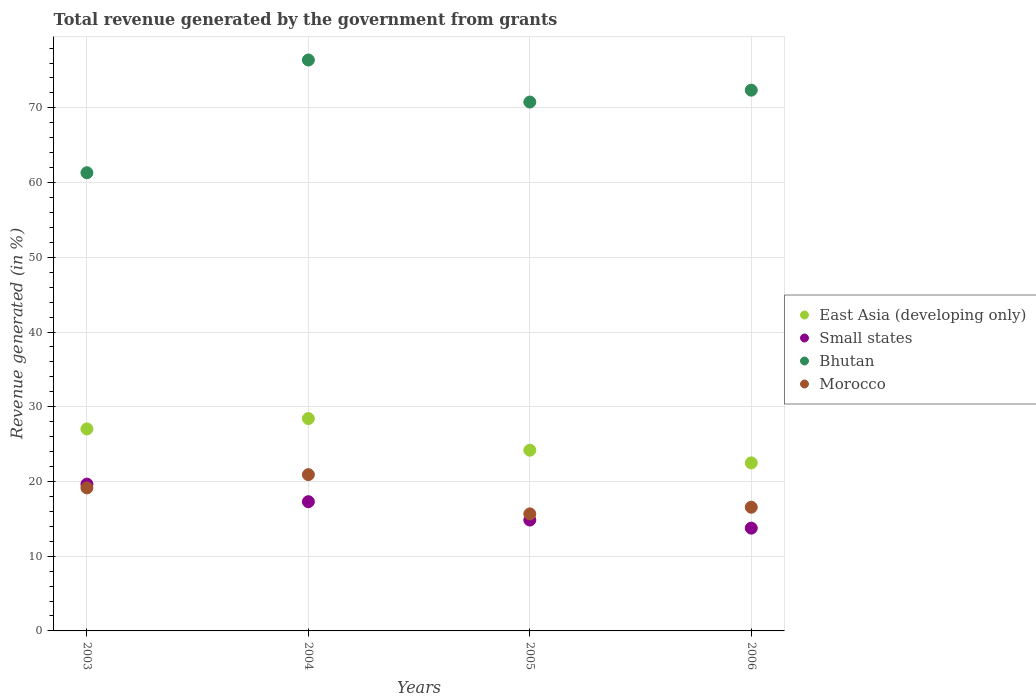What is the total revenue generated in Small states in 2005?
Ensure brevity in your answer.  14.84. Across all years, what is the maximum total revenue generated in East Asia (developing only)?
Your answer should be compact. 28.42. Across all years, what is the minimum total revenue generated in Small states?
Ensure brevity in your answer.  13.76. In which year was the total revenue generated in East Asia (developing only) minimum?
Your response must be concise. 2006. What is the total total revenue generated in Small states in the graph?
Ensure brevity in your answer.  65.54. What is the difference between the total revenue generated in Bhutan in 2004 and that in 2005?
Your answer should be compact. 5.63. What is the difference between the total revenue generated in East Asia (developing only) in 2004 and the total revenue generated in Small states in 2003?
Provide a succinct answer. 8.77. What is the average total revenue generated in Small states per year?
Your response must be concise. 16.38. In the year 2003, what is the difference between the total revenue generated in East Asia (developing only) and total revenue generated in Morocco?
Ensure brevity in your answer.  7.9. What is the ratio of the total revenue generated in Bhutan in 2003 to that in 2004?
Your answer should be compact. 0.8. What is the difference between the highest and the second highest total revenue generated in East Asia (developing only)?
Offer a very short reply. 1.39. What is the difference between the highest and the lowest total revenue generated in East Asia (developing only)?
Your answer should be very brief. 5.93. In how many years, is the total revenue generated in East Asia (developing only) greater than the average total revenue generated in East Asia (developing only) taken over all years?
Your response must be concise. 2. Does the total revenue generated in East Asia (developing only) monotonically increase over the years?
Your answer should be very brief. No. How many dotlines are there?
Provide a short and direct response. 4. What is the difference between two consecutive major ticks on the Y-axis?
Offer a terse response. 10. Does the graph contain any zero values?
Provide a succinct answer. No. Does the graph contain grids?
Make the answer very short. Yes. Where does the legend appear in the graph?
Ensure brevity in your answer.  Center right. How many legend labels are there?
Offer a very short reply. 4. What is the title of the graph?
Offer a very short reply. Total revenue generated by the government from grants. Does "Eritrea" appear as one of the legend labels in the graph?
Provide a short and direct response. No. What is the label or title of the Y-axis?
Keep it short and to the point. Revenue generated (in %). What is the Revenue generated (in %) in East Asia (developing only) in 2003?
Offer a terse response. 27.03. What is the Revenue generated (in %) of Small states in 2003?
Give a very brief answer. 19.65. What is the Revenue generated (in %) of Bhutan in 2003?
Provide a succinct answer. 61.32. What is the Revenue generated (in %) of Morocco in 2003?
Offer a very short reply. 19.14. What is the Revenue generated (in %) of East Asia (developing only) in 2004?
Make the answer very short. 28.42. What is the Revenue generated (in %) in Small states in 2004?
Keep it short and to the point. 17.3. What is the Revenue generated (in %) of Bhutan in 2004?
Give a very brief answer. 76.41. What is the Revenue generated (in %) in Morocco in 2004?
Give a very brief answer. 20.92. What is the Revenue generated (in %) of East Asia (developing only) in 2005?
Ensure brevity in your answer.  24.19. What is the Revenue generated (in %) in Small states in 2005?
Provide a short and direct response. 14.84. What is the Revenue generated (in %) in Bhutan in 2005?
Your answer should be very brief. 70.78. What is the Revenue generated (in %) of Morocco in 2005?
Provide a short and direct response. 15.66. What is the Revenue generated (in %) in East Asia (developing only) in 2006?
Ensure brevity in your answer.  22.49. What is the Revenue generated (in %) of Small states in 2006?
Offer a very short reply. 13.76. What is the Revenue generated (in %) in Bhutan in 2006?
Make the answer very short. 72.37. What is the Revenue generated (in %) of Morocco in 2006?
Offer a very short reply. 16.55. Across all years, what is the maximum Revenue generated (in %) of East Asia (developing only)?
Offer a terse response. 28.42. Across all years, what is the maximum Revenue generated (in %) in Small states?
Your response must be concise. 19.65. Across all years, what is the maximum Revenue generated (in %) in Bhutan?
Keep it short and to the point. 76.41. Across all years, what is the maximum Revenue generated (in %) in Morocco?
Keep it short and to the point. 20.92. Across all years, what is the minimum Revenue generated (in %) in East Asia (developing only)?
Provide a succinct answer. 22.49. Across all years, what is the minimum Revenue generated (in %) in Small states?
Make the answer very short. 13.76. Across all years, what is the minimum Revenue generated (in %) of Bhutan?
Provide a short and direct response. 61.32. Across all years, what is the minimum Revenue generated (in %) of Morocco?
Offer a very short reply. 15.66. What is the total Revenue generated (in %) in East Asia (developing only) in the graph?
Your answer should be compact. 102.13. What is the total Revenue generated (in %) in Small states in the graph?
Your response must be concise. 65.54. What is the total Revenue generated (in %) in Bhutan in the graph?
Ensure brevity in your answer.  280.88. What is the total Revenue generated (in %) in Morocco in the graph?
Give a very brief answer. 72.27. What is the difference between the Revenue generated (in %) in East Asia (developing only) in 2003 and that in 2004?
Your answer should be compact. -1.39. What is the difference between the Revenue generated (in %) of Small states in 2003 and that in 2004?
Provide a succinct answer. 2.35. What is the difference between the Revenue generated (in %) in Bhutan in 2003 and that in 2004?
Ensure brevity in your answer.  -15.09. What is the difference between the Revenue generated (in %) in Morocco in 2003 and that in 2004?
Give a very brief answer. -1.78. What is the difference between the Revenue generated (in %) in East Asia (developing only) in 2003 and that in 2005?
Make the answer very short. 2.85. What is the difference between the Revenue generated (in %) of Small states in 2003 and that in 2005?
Give a very brief answer. 4.81. What is the difference between the Revenue generated (in %) in Bhutan in 2003 and that in 2005?
Give a very brief answer. -9.46. What is the difference between the Revenue generated (in %) in Morocco in 2003 and that in 2005?
Ensure brevity in your answer.  3.48. What is the difference between the Revenue generated (in %) in East Asia (developing only) in 2003 and that in 2006?
Provide a succinct answer. 4.55. What is the difference between the Revenue generated (in %) in Small states in 2003 and that in 2006?
Your answer should be very brief. 5.89. What is the difference between the Revenue generated (in %) in Bhutan in 2003 and that in 2006?
Your answer should be compact. -11.05. What is the difference between the Revenue generated (in %) in Morocco in 2003 and that in 2006?
Your answer should be very brief. 2.59. What is the difference between the Revenue generated (in %) in East Asia (developing only) in 2004 and that in 2005?
Provide a succinct answer. 4.24. What is the difference between the Revenue generated (in %) in Small states in 2004 and that in 2005?
Ensure brevity in your answer.  2.46. What is the difference between the Revenue generated (in %) of Bhutan in 2004 and that in 2005?
Provide a short and direct response. 5.63. What is the difference between the Revenue generated (in %) of Morocco in 2004 and that in 2005?
Provide a succinct answer. 5.25. What is the difference between the Revenue generated (in %) of East Asia (developing only) in 2004 and that in 2006?
Offer a very short reply. 5.93. What is the difference between the Revenue generated (in %) of Small states in 2004 and that in 2006?
Provide a short and direct response. 3.54. What is the difference between the Revenue generated (in %) in Bhutan in 2004 and that in 2006?
Offer a very short reply. 4.04. What is the difference between the Revenue generated (in %) of Morocco in 2004 and that in 2006?
Give a very brief answer. 4.36. What is the difference between the Revenue generated (in %) in East Asia (developing only) in 2005 and that in 2006?
Your answer should be very brief. 1.7. What is the difference between the Revenue generated (in %) of Small states in 2005 and that in 2006?
Keep it short and to the point. 1.08. What is the difference between the Revenue generated (in %) of Bhutan in 2005 and that in 2006?
Offer a terse response. -1.59. What is the difference between the Revenue generated (in %) of Morocco in 2005 and that in 2006?
Give a very brief answer. -0.89. What is the difference between the Revenue generated (in %) in East Asia (developing only) in 2003 and the Revenue generated (in %) in Small states in 2004?
Provide a short and direct response. 9.74. What is the difference between the Revenue generated (in %) of East Asia (developing only) in 2003 and the Revenue generated (in %) of Bhutan in 2004?
Provide a succinct answer. -49.38. What is the difference between the Revenue generated (in %) of East Asia (developing only) in 2003 and the Revenue generated (in %) of Morocco in 2004?
Make the answer very short. 6.12. What is the difference between the Revenue generated (in %) of Small states in 2003 and the Revenue generated (in %) of Bhutan in 2004?
Your answer should be compact. -56.76. What is the difference between the Revenue generated (in %) in Small states in 2003 and the Revenue generated (in %) in Morocco in 2004?
Offer a terse response. -1.27. What is the difference between the Revenue generated (in %) of Bhutan in 2003 and the Revenue generated (in %) of Morocco in 2004?
Provide a short and direct response. 40.4. What is the difference between the Revenue generated (in %) in East Asia (developing only) in 2003 and the Revenue generated (in %) in Small states in 2005?
Provide a succinct answer. 12.2. What is the difference between the Revenue generated (in %) of East Asia (developing only) in 2003 and the Revenue generated (in %) of Bhutan in 2005?
Your answer should be very brief. -43.75. What is the difference between the Revenue generated (in %) in East Asia (developing only) in 2003 and the Revenue generated (in %) in Morocco in 2005?
Provide a succinct answer. 11.37. What is the difference between the Revenue generated (in %) of Small states in 2003 and the Revenue generated (in %) of Bhutan in 2005?
Offer a very short reply. -51.14. What is the difference between the Revenue generated (in %) of Small states in 2003 and the Revenue generated (in %) of Morocco in 2005?
Provide a succinct answer. 3.98. What is the difference between the Revenue generated (in %) in Bhutan in 2003 and the Revenue generated (in %) in Morocco in 2005?
Your response must be concise. 45.66. What is the difference between the Revenue generated (in %) in East Asia (developing only) in 2003 and the Revenue generated (in %) in Small states in 2006?
Give a very brief answer. 13.28. What is the difference between the Revenue generated (in %) of East Asia (developing only) in 2003 and the Revenue generated (in %) of Bhutan in 2006?
Make the answer very short. -45.34. What is the difference between the Revenue generated (in %) of East Asia (developing only) in 2003 and the Revenue generated (in %) of Morocco in 2006?
Your response must be concise. 10.48. What is the difference between the Revenue generated (in %) in Small states in 2003 and the Revenue generated (in %) in Bhutan in 2006?
Your response must be concise. -52.72. What is the difference between the Revenue generated (in %) of Small states in 2003 and the Revenue generated (in %) of Morocco in 2006?
Provide a short and direct response. 3.09. What is the difference between the Revenue generated (in %) of Bhutan in 2003 and the Revenue generated (in %) of Morocco in 2006?
Your response must be concise. 44.77. What is the difference between the Revenue generated (in %) in East Asia (developing only) in 2004 and the Revenue generated (in %) in Small states in 2005?
Your response must be concise. 13.58. What is the difference between the Revenue generated (in %) of East Asia (developing only) in 2004 and the Revenue generated (in %) of Bhutan in 2005?
Ensure brevity in your answer.  -42.36. What is the difference between the Revenue generated (in %) of East Asia (developing only) in 2004 and the Revenue generated (in %) of Morocco in 2005?
Your answer should be very brief. 12.76. What is the difference between the Revenue generated (in %) of Small states in 2004 and the Revenue generated (in %) of Bhutan in 2005?
Keep it short and to the point. -53.49. What is the difference between the Revenue generated (in %) of Small states in 2004 and the Revenue generated (in %) of Morocco in 2005?
Keep it short and to the point. 1.63. What is the difference between the Revenue generated (in %) of Bhutan in 2004 and the Revenue generated (in %) of Morocco in 2005?
Provide a succinct answer. 60.75. What is the difference between the Revenue generated (in %) in East Asia (developing only) in 2004 and the Revenue generated (in %) in Small states in 2006?
Offer a terse response. 14.66. What is the difference between the Revenue generated (in %) of East Asia (developing only) in 2004 and the Revenue generated (in %) of Bhutan in 2006?
Make the answer very short. -43.95. What is the difference between the Revenue generated (in %) in East Asia (developing only) in 2004 and the Revenue generated (in %) in Morocco in 2006?
Ensure brevity in your answer.  11.87. What is the difference between the Revenue generated (in %) of Small states in 2004 and the Revenue generated (in %) of Bhutan in 2006?
Your answer should be very brief. -55.08. What is the difference between the Revenue generated (in %) of Small states in 2004 and the Revenue generated (in %) of Morocco in 2006?
Make the answer very short. 0.74. What is the difference between the Revenue generated (in %) in Bhutan in 2004 and the Revenue generated (in %) in Morocco in 2006?
Your answer should be very brief. 59.86. What is the difference between the Revenue generated (in %) of East Asia (developing only) in 2005 and the Revenue generated (in %) of Small states in 2006?
Provide a succinct answer. 10.43. What is the difference between the Revenue generated (in %) in East Asia (developing only) in 2005 and the Revenue generated (in %) in Bhutan in 2006?
Provide a short and direct response. -48.19. What is the difference between the Revenue generated (in %) in East Asia (developing only) in 2005 and the Revenue generated (in %) in Morocco in 2006?
Provide a succinct answer. 7.63. What is the difference between the Revenue generated (in %) in Small states in 2005 and the Revenue generated (in %) in Bhutan in 2006?
Your answer should be compact. -57.53. What is the difference between the Revenue generated (in %) in Small states in 2005 and the Revenue generated (in %) in Morocco in 2006?
Provide a succinct answer. -1.72. What is the difference between the Revenue generated (in %) of Bhutan in 2005 and the Revenue generated (in %) of Morocco in 2006?
Your answer should be compact. 54.23. What is the average Revenue generated (in %) in East Asia (developing only) per year?
Offer a terse response. 25.53. What is the average Revenue generated (in %) of Small states per year?
Make the answer very short. 16.38. What is the average Revenue generated (in %) of Bhutan per year?
Make the answer very short. 70.22. What is the average Revenue generated (in %) of Morocco per year?
Provide a short and direct response. 18.07. In the year 2003, what is the difference between the Revenue generated (in %) of East Asia (developing only) and Revenue generated (in %) of Small states?
Your answer should be very brief. 7.39. In the year 2003, what is the difference between the Revenue generated (in %) of East Asia (developing only) and Revenue generated (in %) of Bhutan?
Keep it short and to the point. -34.28. In the year 2003, what is the difference between the Revenue generated (in %) of East Asia (developing only) and Revenue generated (in %) of Morocco?
Ensure brevity in your answer.  7.9. In the year 2003, what is the difference between the Revenue generated (in %) of Small states and Revenue generated (in %) of Bhutan?
Offer a terse response. -41.67. In the year 2003, what is the difference between the Revenue generated (in %) of Small states and Revenue generated (in %) of Morocco?
Offer a very short reply. 0.51. In the year 2003, what is the difference between the Revenue generated (in %) in Bhutan and Revenue generated (in %) in Morocco?
Offer a very short reply. 42.18. In the year 2004, what is the difference between the Revenue generated (in %) of East Asia (developing only) and Revenue generated (in %) of Small states?
Offer a terse response. 11.13. In the year 2004, what is the difference between the Revenue generated (in %) in East Asia (developing only) and Revenue generated (in %) in Bhutan?
Make the answer very short. -47.99. In the year 2004, what is the difference between the Revenue generated (in %) in East Asia (developing only) and Revenue generated (in %) in Morocco?
Offer a terse response. 7.51. In the year 2004, what is the difference between the Revenue generated (in %) of Small states and Revenue generated (in %) of Bhutan?
Your answer should be compact. -59.11. In the year 2004, what is the difference between the Revenue generated (in %) in Small states and Revenue generated (in %) in Morocco?
Make the answer very short. -3.62. In the year 2004, what is the difference between the Revenue generated (in %) of Bhutan and Revenue generated (in %) of Morocco?
Ensure brevity in your answer.  55.49. In the year 2005, what is the difference between the Revenue generated (in %) of East Asia (developing only) and Revenue generated (in %) of Small states?
Your answer should be compact. 9.35. In the year 2005, what is the difference between the Revenue generated (in %) of East Asia (developing only) and Revenue generated (in %) of Bhutan?
Offer a very short reply. -46.6. In the year 2005, what is the difference between the Revenue generated (in %) of East Asia (developing only) and Revenue generated (in %) of Morocco?
Your answer should be compact. 8.52. In the year 2005, what is the difference between the Revenue generated (in %) of Small states and Revenue generated (in %) of Bhutan?
Offer a terse response. -55.94. In the year 2005, what is the difference between the Revenue generated (in %) of Small states and Revenue generated (in %) of Morocco?
Offer a very short reply. -0.83. In the year 2005, what is the difference between the Revenue generated (in %) in Bhutan and Revenue generated (in %) in Morocco?
Make the answer very short. 55.12. In the year 2006, what is the difference between the Revenue generated (in %) in East Asia (developing only) and Revenue generated (in %) in Small states?
Give a very brief answer. 8.73. In the year 2006, what is the difference between the Revenue generated (in %) in East Asia (developing only) and Revenue generated (in %) in Bhutan?
Provide a succinct answer. -49.88. In the year 2006, what is the difference between the Revenue generated (in %) of East Asia (developing only) and Revenue generated (in %) of Morocco?
Make the answer very short. 5.93. In the year 2006, what is the difference between the Revenue generated (in %) of Small states and Revenue generated (in %) of Bhutan?
Your response must be concise. -58.61. In the year 2006, what is the difference between the Revenue generated (in %) of Small states and Revenue generated (in %) of Morocco?
Make the answer very short. -2.8. In the year 2006, what is the difference between the Revenue generated (in %) in Bhutan and Revenue generated (in %) in Morocco?
Provide a short and direct response. 55.82. What is the ratio of the Revenue generated (in %) in East Asia (developing only) in 2003 to that in 2004?
Your response must be concise. 0.95. What is the ratio of the Revenue generated (in %) in Small states in 2003 to that in 2004?
Your answer should be very brief. 1.14. What is the ratio of the Revenue generated (in %) of Bhutan in 2003 to that in 2004?
Your response must be concise. 0.8. What is the ratio of the Revenue generated (in %) in Morocco in 2003 to that in 2004?
Provide a succinct answer. 0.92. What is the ratio of the Revenue generated (in %) of East Asia (developing only) in 2003 to that in 2005?
Make the answer very short. 1.12. What is the ratio of the Revenue generated (in %) of Small states in 2003 to that in 2005?
Your response must be concise. 1.32. What is the ratio of the Revenue generated (in %) in Bhutan in 2003 to that in 2005?
Offer a terse response. 0.87. What is the ratio of the Revenue generated (in %) of Morocco in 2003 to that in 2005?
Your answer should be very brief. 1.22. What is the ratio of the Revenue generated (in %) of East Asia (developing only) in 2003 to that in 2006?
Give a very brief answer. 1.2. What is the ratio of the Revenue generated (in %) of Small states in 2003 to that in 2006?
Your response must be concise. 1.43. What is the ratio of the Revenue generated (in %) in Bhutan in 2003 to that in 2006?
Your answer should be very brief. 0.85. What is the ratio of the Revenue generated (in %) of Morocco in 2003 to that in 2006?
Provide a short and direct response. 1.16. What is the ratio of the Revenue generated (in %) in East Asia (developing only) in 2004 to that in 2005?
Provide a succinct answer. 1.18. What is the ratio of the Revenue generated (in %) of Small states in 2004 to that in 2005?
Offer a very short reply. 1.17. What is the ratio of the Revenue generated (in %) in Bhutan in 2004 to that in 2005?
Your response must be concise. 1.08. What is the ratio of the Revenue generated (in %) of Morocco in 2004 to that in 2005?
Offer a very short reply. 1.34. What is the ratio of the Revenue generated (in %) of East Asia (developing only) in 2004 to that in 2006?
Your answer should be compact. 1.26. What is the ratio of the Revenue generated (in %) in Small states in 2004 to that in 2006?
Provide a short and direct response. 1.26. What is the ratio of the Revenue generated (in %) of Bhutan in 2004 to that in 2006?
Offer a terse response. 1.06. What is the ratio of the Revenue generated (in %) in Morocco in 2004 to that in 2006?
Offer a terse response. 1.26. What is the ratio of the Revenue generated (in %) in East Asia (developing only) in 2005 to that in 2006?
Make the answer very short. 1.08. What is the ratio of the Revenue generated (in %) of Small states in 2005 to that in 2006?
Give a very brief answer. 1.08. What is the ratio of the Revenue generated (in %) of Morocco in 2005 to that in 2006?
Offer a terse response. 0.95. What is the difference between the highest and the second highest Revenue generated (in %) in East Asia (developing only)?
Make the answer very short. 1.39. What is the difference between the highest and the second highest Revenue generated (in %) in Small states?
Make the answer very short. 2.35. What is the difference between the highest and the second highest Revenue generated (in %) of Bhutan?
Offer a very short reply. 4.04. What is the difference between the highest and the second highest Revenue generated (in %) of Morocco?
Keep it short and to the point. 1.78. What is the difference between the highest and the lowest Revenue generated (in %) of East Asia (developing only)?
Your answer should be very brief. 5.93. What is the difference between the highest and the lowest Revenue generated (in %) of Small states?
Your answer should be compact. 5.89. What is the difference between the highest and the lowest Revenue generated (in %) in Bhutan?
Your answer should be very brief. 15.09. What is the difference between the highest and the lowest Revenue generated (in %) of Morocco?
Provide a succinct answer. 5.25. 